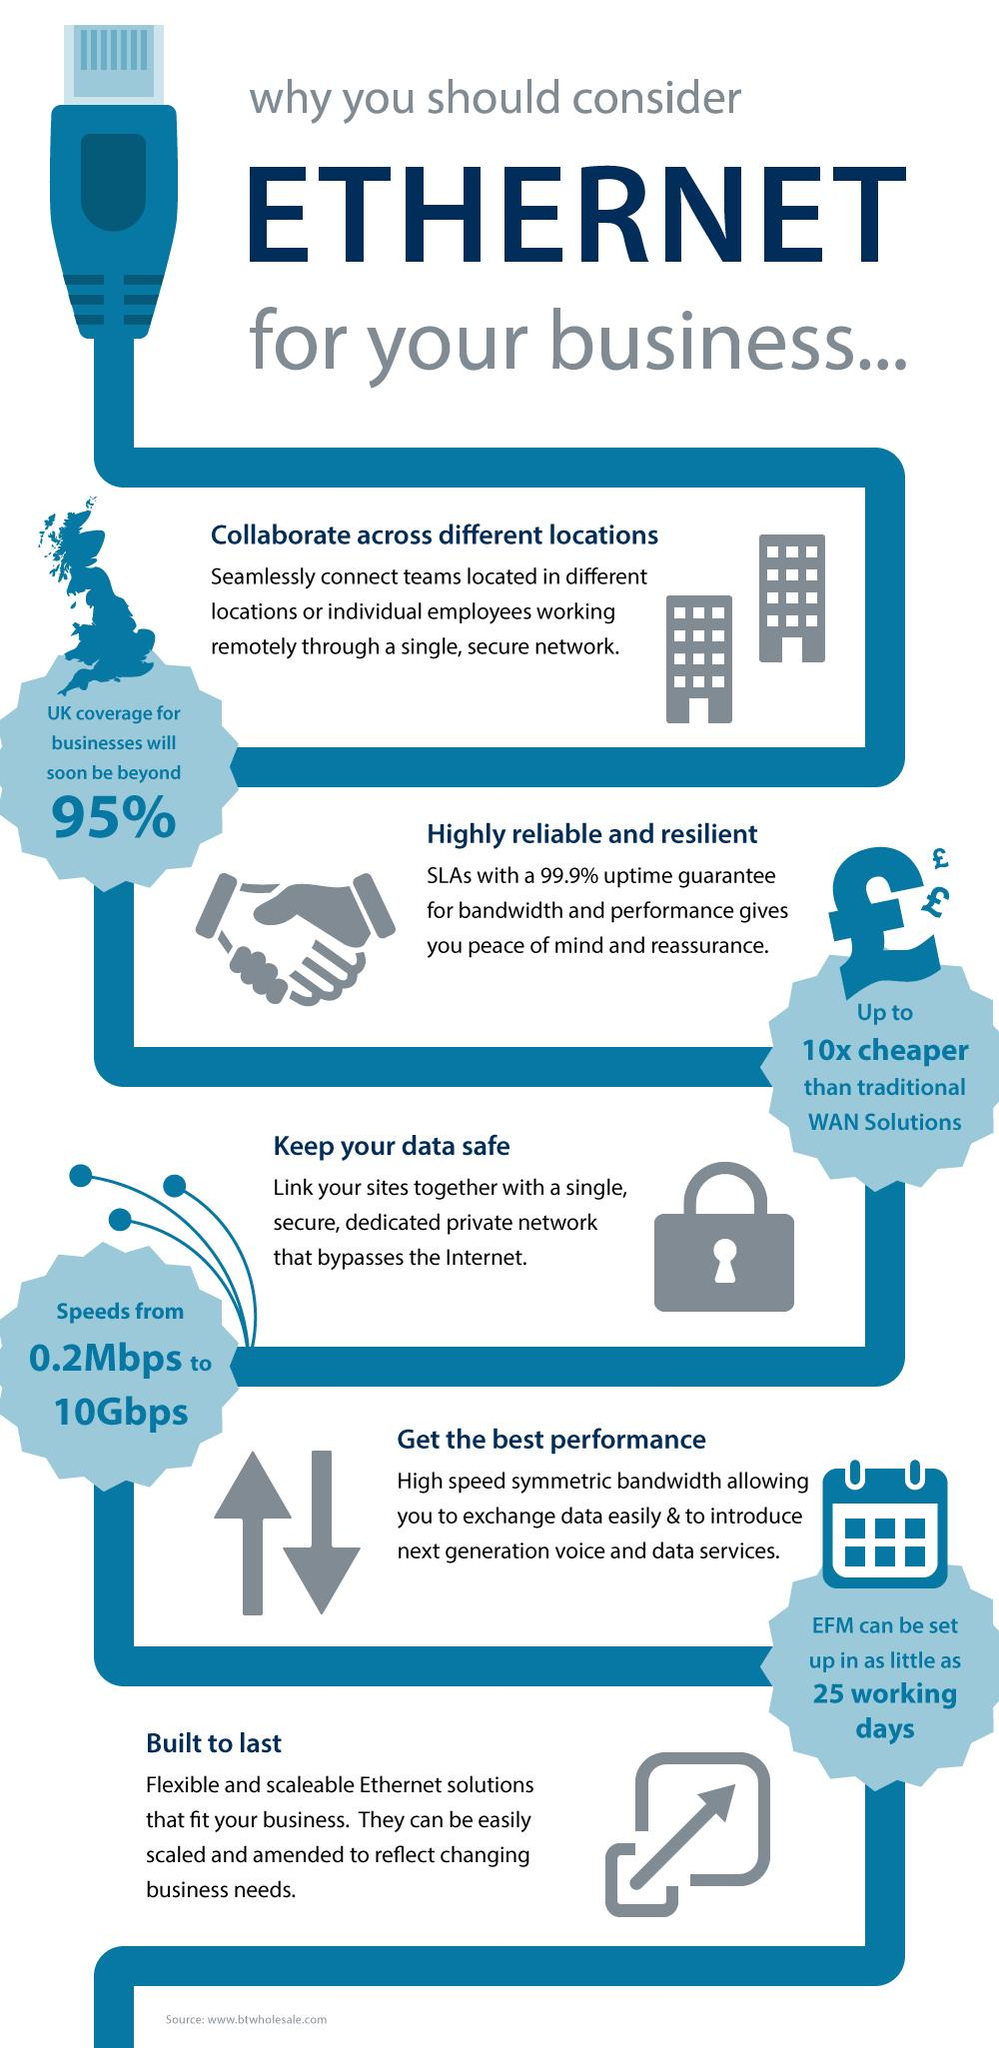Outline some significant characteristics in this image. There are five reasons for considering Ethernet for business activities. 